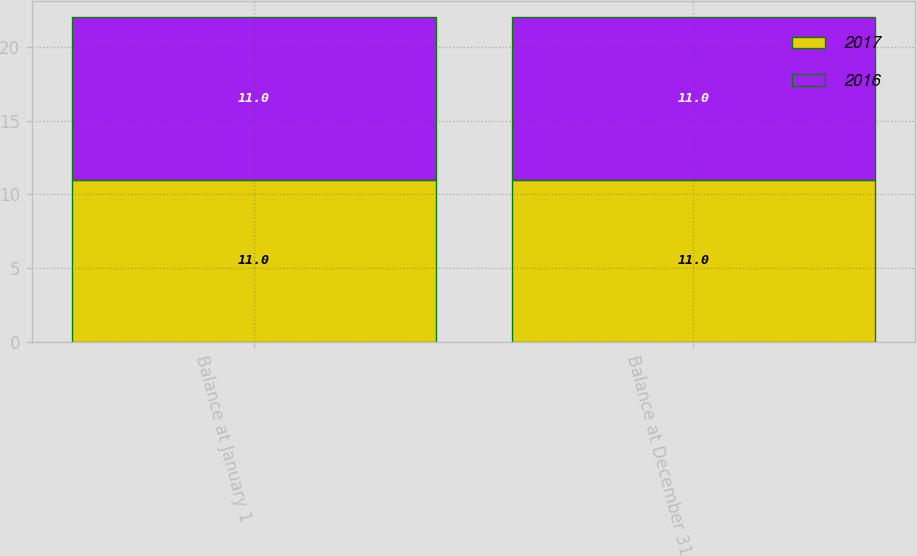Convert chart to OTSL. <chart><loc_0><loc_0><loc_500><loc_500><stacked_bar_chart><ecel><fcel>Balance at January 1<fcel>Balance at December 31<nl><fcel>2017<fcel>11<fcel>11<nl><fcel>2016<fcel>11<fcel>11<nl></chart> 